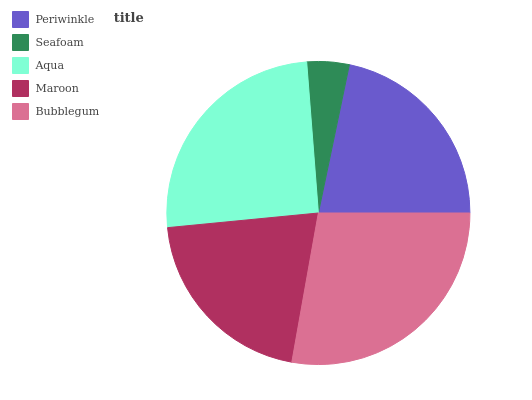Is Seafoam the minimum?
Answer yes or no. Yes. Is Bubblegum the maximum?
Answer yes or no. Yes. Is Aqua the minimum?
Answer yes or no. No. Is Aqua the maximum?
Answer yes or no. No. Is Aqua greater than Seafoam?
Answer yes or no. Yes. Is Seafoam less than Aqua?
Answer yes or no. Yes. Is Seafoam greater than Aqua?
Answer yes or no. No. Is Aqua less than Seafoam?
Answer yes or no. No. Is Periwinkle the high median?
Answer yes or no. Yes. Is Periwinkle the low median?
Answer yes or no. Yes. Is Aqua the high median?
Answer yes or no. No. Is Aqua the low median?
Answer yes or no. No. 